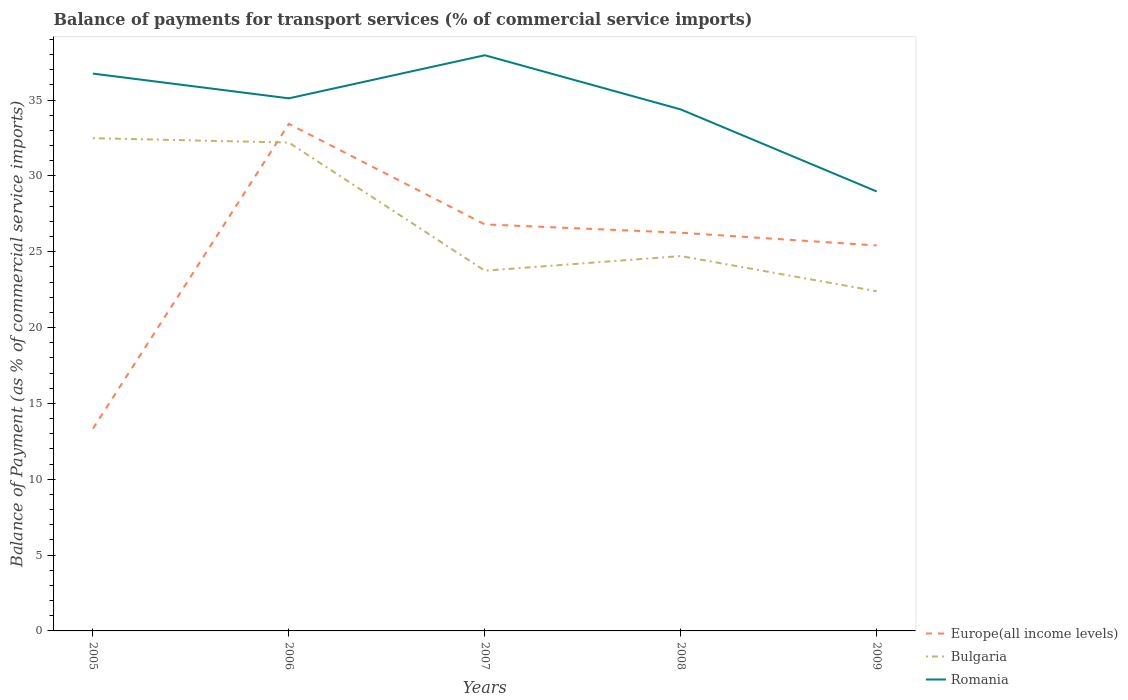How many different coloured lines are there?
Keep it short and to the point. 3. Does the line corresponding to Europe(all income levels) intersect with the line corresponding to Bulgaria?
Keep it short and to the point. Yes. Across all years, what is the maximum balance of payments for transport services in Bulgaria?
Give a very brief answer. 22.4. In which year was the balance of payments for transport services in Romania maximum?
Make the answer very short. 2009. What is the total balance of payments for transport services in Romania in the graph?
Make the answer very short. 5.41. What is the difference between the highest and the second highest balance of payments for transport services in Romania?
Your response must be concise. 8.98. What is the difference between the highest and the lowest balance of payments for transport services in Romania?
Ensure brevity in your answer.  3. Is the balance of payments for transport services in Bulgaria strictly greater than the balance of payments for transport services in Romania over the years?
Your response must be concise. Yes. How many lines are there?
Your response must be concise. 3. How many years are there in the graph?
Offer a terse response. 5. What is the difference between two consecutive major ticks on the Y-axis?
Provide a succinct answer. 5. Are the values on the major ticks of Y-axis written in scientific E-notation?
Give a very brief answer. No. Does the graph contain grids?
Provide a short and direct response. No. Where does the legend appear in the graph?
Provide a succinct answer. Bottom right. How are the legend labels stacked?
Make the answer very short. Vertical. What is the title of the graph?
Your answer should be compact. Balance of payments for transport services (% of commercial service imports). What is the label or title of the X-axis?
Keep it short and to the point. Years. What is the label or title of the Y-axis?
Offer a terse response. Balance of Payment (as % of commercial service imports). What is the Balance of Payment (as % of commercial service imports) of Europe(all income levels) in 2005?
Provide a short and direct response. 13.34. What is the Balance of Payment (as % of commercial service imports) of Bulgaria in 2005?
Offer a very short reply. 32.49. What is the Balance of Payment (as % of commercial service imports) of Romania in 2005?
Make the answer very short. 36.75. What is the Balance of Payment (as % of commercial service imports) of Europe(all income levels) in 2006?
Your answer should be very brief. 33.44. What is the Balance of Payment (as % of commercial service imports) of Bulgaria in 2006?
Your answer should be compact. 32.2. What is the Balance of Payment (as % of commercial service imports) of Romania in 2006?
Provide a succinct answer. 35.12. What is the Balance of Payment (as % of commercial service imports) in Europe(all income levels) in 2007?
Keep it short and to the point. 26.81. What is the Balance of Payment (as % of commercial service imports) of Bulgaria in 2007?
Offer a terse response. 23.75. What is the Balance of Payment (as % of commercial service imports) in Romania in 2007?
Make the answer very short. 37.96. What is the Balance of Payment (as % of commercial service imports) of Europe(all income levels) in 2008?
Ensure brevity in your answer.  26.26. What is the Balance of Payment (as % of commercial service imports) of Bulgaria in 2008?
Make the answer very short. 24.72. What is the Balance of Payment (as % of commercial service imports) of Romania in 2008?
Give a very brief answer. 34.39. What is the Balance of Payment (as % of commercial service imports) in Europe(all income levels) in 2009?
Provide a short and direct response. 25.42. What is the Balance of Payment (as % of commercial service imports) of Bulgaria in 2009?
Your answer should be very brief. 22.4. What is the Balance of Payment (as % of commercial service imports) in Romania in 2009?
Offer a very short reply. 28.98. Across all years, what is the maximum Balance of Payment (as % of commercial service imports) of Europe(all income levels)?
Keep it short and to the point. 33.44. Across all years, what is the maximum Balance of Payment (as % of commercial service imports) in Bulgaria?
Keep it short and to the point. 32.49. Across all years, what is the maximum Balance of Payment (as % of commercial service imports) in Romania?
Offer a very short reply. 37.96. Across all years, what is the minimum Balance of Payment (as % of commercial service imports) of Europe(all income levels)?
Provide a succinct answer. 13.34. Across all years, what is the minimum Balance of Payment (as % of commercial service imports) of Bulgaria?
Ensure brevity in your answer.  22.4. Across all years, what is the minimum Balance of Payment (as % of commercial service imports) in Romania?
Your answer should be compact. 28.98. What is the total Balance of Payment (as % of commercial service imports) of Europe(all income levels) in the graph?
Your answer should be very brief. 125.26. What is the total Balance of Payment (as % of commercial service imports) in Bulgaria in the graph?
Your answer should be compact. 135.57. What is the total Balance of Payment (as % of commercial service imports) of Romania in the graph?
Your answer should be very brief. 173.2. What is the difference between the Balance of Payment (as % of commercial service imports) in Europe(all income levels) in 2005 and that in 2006?
Your answer should be compact. -20.1. What is the difference between the Balance of Payment (as % of commercial service imports) of Bulgaria in 2005 and that in 2006?
Ensure brevity in your answer.  0.29. What is the difference between the Balance of Payment (as % of commercial service imports) of Romania in 2005 and that in 2006?
Your response must be concise. 1.63. What is the difference between the Balance of Payment (as % of commercial service imports) in Europe(all income levels) in 2005 and that in 2007?
Offer a terse response. -13.47. What is the difference between the Balance of Payment (as % of commercial service imports) in Bulgaria in 2005 and that in 2007?
Provide a succinct answer. 8.74. What is the difference between the Balance of Payment (as % of commercial service imports) in Romania in 2005 and that in 2007?
Keep it short and to the point. -1.21. What is the difference between the Balance of Payment (as % of commercial service imports) of Europe(all income levels) in 2005 and that in 2008?
Your answer should be compact. -12.92. What is the difference between the Balance of Payment (as % of commercial service imports) of Bulgaria in 2005 and that in 2008?
Offer a very short reply. 7.77. What is the difference between the Balance of Payment (as % of commercial service imports) of Romania in 2005 and that in 2008?
Your response must be concise. 2.36. What is the difference between the Balance of Payment (as % of commercial service imports) of Europe(all income levels) in 2005 and that in 2009?
Keep it short and to the point. -12.08. What is the difference between the Balance of Payment (as % of commercial service imports) in Bulgaria in 2005 and that in 2009?
Ensure brevity in your answer.  10.09. What is the difference between the Balance of Payment (as % of commercial service imports) of Romania in 2005 and that in 2009?
Make the answer very short. 7.77. What is the difference between the Balance of Payment (as % of commercial service imports) in Europe(all income levels) in 2006 and that in 2007?
Ensure brevity in your answer.  6.63. What is the difference between the Balance of Payment (as % of commercial service imports) of Bulgaria in 2006 and that in 2007?
Provide a short and direct response. 8.45. What is the difference between the Balance of Payment (as % of commercial service imports) in Romania in 2006 and that in 2007?
Offer a very short reply. -2.84. What is the difference between the Balance of Payment (as % of commercial service imports) of Europe(all income levels) in 2006 and that in 2008?
Provide a short and direct response. 7.18. What is the difference between the Balance of Payment (as % of commercial service imports) in Bulgaria in 2006 and that in 2008?
Provide a short and direct response. 7.48. What is the difference between the Balance of Payment (as % of commercial service imports) of Romania in 2006 and that in 2008?
Ensure brevity in your answer.  0.73. What is the difference between the Balance of Payment (as % of commercial service imports) of Europe(all income levels) in 2006 and that in 2009?
Provide a short and direct response. 8.02. What is the difference between the Balance of Payment (as % of commercial service imports) in Bulgaria in 2006 and that in 2009?
Ensure brevity in your answer.  9.8. What is the difference between the Balance of Payment (as % of commercial service imports) of Romania in 2006 and that in 2009?
Your response must be concise. 6.14. What is the difference between the Balance of Payment (as % of commercial service imports) of Europe(all income levels) in 2007 and that in 2008?
Keep it short and to the point. 0.55. What is the difference between the Balance of Payment (as % of commercial service imports) in Bulgaria in 2007 and that in 2008?
Offer a terse response. -0.96. What is the difference between the Balance of Payment (as % of commercial service imports) in Romania in 2007 and that in 2008?
Make the answer very short. 3.57. What is the difference between the Balance of Payment (as % of commercial service imports) of Europe(all income levels) in 2007 and that in 2009?
Ensure brevity in your answer.  1.39. What is the difference between the Balance of Payment (as % of commercial service imports) in Bulgaria in 2007 and that in 2009?
Provide a short and direct response. 1.35. What is the difference between the Balance of Payment (as % of commercial service imports) in Romania in 2007 and that in 2009?
Your answer should be very brief. 8.98. What is the difference between the Balance of Payment (as % of commercial service imports) in Europe(all income levels) in 2008 and that in 2009?
Offer a very short reply. 0.84. What is the difference between the Balance of Payment (as % of commercial service imports) of Bulgaria in 2008 and that in 2009?
Keep it short and to the point. 2.32. What is the difference between the Balance of Payment (as % of commercial service imports) of Romania in 2008 and that in 2009?
Keep it short and to the point. 5.41. What is the difference between the Balance of Payment (as % of commercial service imports) in Europe(all income levels) in 2005 and the Balance of Payment (as % of commercial service imports) in Bulgaria in 2006?
Make the answer very short. -18.87. What is the difference between the Balance of Payment (as % of commercial service imports) of Europe(all income levels) in 2005 and the Balance of Payment (as % of commercial service imports) of Romania in 2006?
Your answer should be very brief. -21.78. What is the difference between the Balance of Payment (as % of commercial service imports) of Bulgaria in 2005 and the Balance of Payment (as % of commercial service imports) of Romania in 2006?
Make the answer very short. -2.63. What is the difference between the Balance of Payment (as % of commercial service imports) of Europe(all income levels) in 2005 and the Balance of Payment (as % of commercial service imports) of Bulgaria in 2007?
Your answer should be very brief. -10.42. What is the difference between the Balance of Payment (as % of commercial service imports) in Europe(all income levels) in 2005 and the Balance of Payment (as % of commercial service imports) in Romania in 2007?
Give a very brief answer. -24.62. What is the difference between the Balance of Payment (as % of commercial service imports) of Bulgaria in 2005 and the Balance of Payment (as % of commercial service imports) of Romania in 2007?
Ensure brevity in your answer.  -5.47. What is the difference between the Balance of Payment (as % of commercial service imports) of Europe(all income levels) in 2005 and the Balance of Payment (as % of commercial service imports) of Bulgaria in 2008?
Make the answer very short. -11.38. What is the difference between the Balance of Payment (as % of commercial service imports) in Europe(all income levels) in 2005 and the Balance of Payment (as % of commercial service imports) in Romania in 2008?
Provide a short and direct response. -21.05. What is the difference between the Balance of Payment (as % of commercial service imports) of Bulgaria in 2005 and the Balance of Payment (as % of commercial service imports) of Romania in 2008?
Ensure brevity in your answer.  -1.89. What is the difference between the Balance of Payment (as % of commercial service imports) of Europe(all income levels) in 2005 and the Balance of Payment (as % of commercial service imports) of Bulgaria in 2009?
Provide a succinct answer. -9.06. What is the difference between the Balance of Payment (as % of commercial service imports) of Europe(all income levels) in 2005 and the Balance of Payment (as % of commercial service imports) of Romania in 2009?
Give a very brief answer. -15.64. What is the difference between the Balance of Payment (as % of commercial service imports) in Bulgaria in 2005 and the Balance of Payment (as % of commercial service imports) in Romania in 2009?
Your answer should be compact. 3.51. What is the difference between the Balance of Payment (as % of commercial service imports) in Europe(all income levels) in 2006 and the Balance of Payment (as % of commercial service imports) in Bulgaria in 2007?
Give a very brief answer. 9.68. What is the difference between the Balance of Payment (as % of commercial service imports) in Europe(all income levels) in 2006 and the Balance of Payment (as % of commercial service imports) in Romania in 2007?
Offer a very short reply. -4.53. What is the difference between the Balance of Payment (as % of commercial service imports) in Bulgaria in 2006 and the Balance of Payment (as % of commercial service imports) in Romania in 2007?
Keep it short and to the point. -5.76. What is the difference between the Balance of Payment (as % of commercial service imports) of Europe(all income levels) in 2006 and the Balance of Payment (as % of commercial service imports) of Bulgaria in 2008?
Offer a terse response. 8.72. What is the difference between the Balance of Payment (as % of commercial service imports) in Europe(all income levels) in 2006 and the Balance of Payment (as % of commercial service imports) in Romania in 2008?
Offer a terse response. -0.95. What is the difference between the Balance of Payment (as % of commercial service imports) in Bulgaria in 2006 and the Balance of Payment (as % of commercial service imports) in Romania in 2008?
Give a very brief answer. -2.19. What is the difference between the Balance of Payment (as % of commercial service imports) of Europe(all income levels) in 2006 and the Balance of Payment (as % of commercial service imports) of Bulgaria in 2009?
Give a very brief answer. 11.04. What is the difference between the Balance of Payment (as % of commercial service imports) of Europe(all income levels) in 2006 and the Balance of Payment (as % of commercial service imports) of Romania in 2009?
Keep it short and to the point. 4.46. What is the difference between the Balance of Payment (as % of commercial service imports) in Bulgaria in 2006 and the Balance of Payment (as % of commercial service imports) in Romania in 2009?
Keep it short and to the point. 3.22. What is the difference between the Balance of Payment (as % of commercial service imports) in Europe(all income levels) in 2007 and the Balance of Payment (as % of commercial service imports) in Bulgaria in 2008?
Provide a succinct answer. 2.09. What is the difference between the Balance of Payment (as % of commercial service imports) of Europe(all income levels) in 2007 and the Balance of Payment (as % of commercial service imports) of Romania in 2008?
Your answer should be very brief. -7.58. What is the difference between the Balance of Payment (as % of commercial service imports) in Bulgaria in 2007 and the Balance of Payment (as % of commercial service imports) in Romania in 2008?
Offer a terse response. -10.63. What is the difference between the Balance of Payment (as % of commercial service imports) of Europe(all income levels) in 2007 and the Balance of Payment (as % of commercial service imports) of Bulgaria in 2009?
Your response must be concise. 4.41. What is the difference between the Balance of Payment (as % of commercial service imports) in Europe(all income levels) in 2007 and the Balance of Payment (as % of commercial service imports) in Romania in 2009?
Your answer should be very brief. -2.17. What is the difference between the Balance of Payment (as % of commercial service imports) in Bulgaria in 2007 and the Balance of Payment (as % of commercial service imports) in Romania in 2009?
Offer a very short reply. -5.22. What is the difference between the Balance of Payment (as % of commercial service imports) of Europe(all income levels) in 2008 and the Balance of Payment (as % of commercial service imports) of Bulgaria in 2009?
Keep it short and to the point. 3.86. What is the difference between the Balance of Payment (as % of commercial service imports) in Europe(all income levels) in 2008 and the Balance of Payment (as % of commercial service imports) in Romania in 2009?
Give a very brief answer. -2.72. What is the difference between the Balance of Payment (as % of commercial service imports) of Bulgaria in 2008 and the Balance of Payment (as % of commercial service imports) of Romania in 2009?
Provide a short and direct response. -4.26. What is the average Balance of Payment (as % of commercial service imports) of Europe(all income levels) per year?
Give a very brief answer. 25.05. What is the average Balance of Payment (as % of commercial service imports) of Bulgaria per year?
Keep it short and to the point. 27.11. What is the average Balance of Payment (as % of commercial service imports) in Romania per year?
Offer a terse response. 34.64. In the year 2005, what is the difference between the Balance of Payment (as % of commercial service imports) in Europe(all income levels) and Balance of Payment (as % of commercial service imports) in Bulgaria?
Keep it short and to the point. -19.16. In the year 2005, what is the difference between the Balance of Payment (as % of commercial service imports) in Europe(all income levels) and Balance of Payment (as % of commercial service imports) in Romania?
Your response must be concise. -23.41. In the year 2005, what is the difference between the Balance of Payment (as % of commercial service imports) of Bulgaria and Balance of Payment (as % of commercial service imports) of Romania?
Your answer should be compact. -4.26. In the year 2006, what is the difference between the Balance of Payment (as % of commercial service imports) in Europe(all income levels) and Balance of Payment (as % of commercial service imports) in Bulgaria?
Give a very brief answer. 1.23. In the year 2006, what is the difference between the Balance of Payment (as % of commercial service imports) of Europe(all income levels) and Balance of Payment (as % of commercial service imports) of Romania?
Give a very brief answer. -1.68. In the year 2006, what is the difference between the Balance of Payment (as % of commercial service imports) of Bulgaria and Balance of Payment (as % of commercial service imports) of Romania?
Your answer should be compact. -2.92. In the year 2007, what is the difference between the Balance of Payment (as % of commercial service imports) of Europe(all income levels) and Balance of Payment (as % of commercial service imports) of Bulgaria?
Provide a succinct answer. 3.05. In the year 2007, what is the difference between the Balance of Payment (as % of commercial service imports) of Europe(all income levels) and Balance of Payment (as % of commercial service imports) of Romania?
Offer a very short reply. -11.15. In the year 2007, what is the difference between the Balance of Payment (as % of commercial service imports) in Bulgaria and Balance of Payment (as % of commercial service imports) in Romania?
Offer a very short reply. -14.21. In the year 2008, what is the difference between the Balance of Payment (as % of commercial service imports) in Europe(all income levels) and Balance of Payment (as % of commercial service imports) in Bulgaria?
Make the answer very short. 1.54. In the year 2008, what is the difference between the Balance of Payment (as % of commercial service imports) of Europe(all income levels) and Balance of Payment (as % of commercial service imports) of Romania?
Offer a terse response. -8.13. In the year 2008, what is the difference between the Balance of Payment (as % of commercial service imports) in Bulgaria and Balance of Payment (as % of commercial service imports) in Romania?
Provide a short and direct response. -9.67. In the year 2009, what is the difference between the Balance of Payment (as % of commercial service imports) of Europe(all income levels) and Balance of Payment (as % of commercial service imports) of Bulgaria?
Your answer should be very brief. 3.02. In the year 2009, what is the difference between the Balance of Payment (as % of commercial service imports) in Europe(all income levels) and Balance of Payment (as % of commercial service imports) in Romania?
Your answer should be very brief. -3.56. In the year 2009, what is the difference between the Balance of Payment (as % of commercial service imports) of Bulgaria and Balance of Payment (as % of commercial service imports) of Romania?
Your answer should be very brief. -6.58. What is the ratio of the Balance of Payment (as % of commercial service imports) in Europe(all income levels) in 2005 to that in 2006?
Provide a short and direct response. 0.4. What is the ratio of the Balance of Payment (as % of commercial service imports) in Bulgaria in 2005 to that in 2006?
Offer a very short reply. 1.01. What is the ratio of the Balance of Payment (as % of commercial service imports) of Romania in 2005 to that in 2006?
Provide a short and direct response. 1.05. What is the ratio of the Balance of Payment (as % of commercial service imports) in Europe(all income levels) in 2005 to that in 2007?
Your answer should be very brief. 0.5. What is the ratio of the Balance of Payment (as % of commercial service imports) in Bulgaria in 2005 to that in 2007?
Your response must be concise. 1.37. What is the ratio of the Balance of Payment (as % of commercial service imports) of Romania in 2005 to that in 2007?
Keep it short and to the point. 0.97. What is the ratio of the Balance of Payment (as % of commercial service imports) of Europe(all income levels) in 2005 to that in 2008?
Provide a short and direct response. 0.51. What is the ratio of the Balance of Payment (as % of commercial service imports) in Bulgaria in 2005 to that in 2008?
Your answer should be very brief. 1.31. What is the ratio of the Balance of Payment (as % of commercial service imports) of Romania in 2005 to that in 2008?
Offer a very short reply. 1.07. What is the ratio of the Balance of Payment (as % of commercial service imports) in Europe(all income levels) in 2005 to that in 2009?
Ensure brevity in your answer.  0.52. What is the ratio of the Balance of Payment (as % of commercial service imports) in Bulgaria in 2005 to that in 2009?
Ensure brevity in your answer.  1.45. What is the ratio of the Balance of Payment (as % of commercial service imports) in Romania in 2005 to that in 2009?
Offer a terse response. 1.27. What is the ratio of the Balance of Payment (as % of commercial service imports) in Europe(all income levels) in 2006 to that in 2007?
Your response must be concise. 1.25. What is the ratio of the Balance of Payment (as % of commercial service imports) of Bulgaria in 2006 to that in 2007?
Your response must be concise. 1.36. What is the ratio of the Balance of Payment (as % of commercial service imports) in Romania in 2006 to that in 2007?
Provide a succinct answer. 0.93. What is the ratio of the Balance of Payment (as % of commercial service imports) of Europe(all income levels) in 2006 to that in 2008?
Give a very brief answer. 1.27. What is the ratio of the Balance of Payment (as % of commercial service imports) of Bulgaria in 2006 to that in 2008?
Offer a very short reply. 1.3. What is the ratio of the Balance of Payment (as % of commercial service imports) in Romania in 2006 to that in 2008?
Provide a succinct answer. 1.02. What is the ratio of the Balance of Payment (as % of commercial service imports) of Europe(all income levels) in 2006 to that in 2009?
Make the answer very short. 1.32. What is the ratio of the Balance of Payment (as % of commercial service imports) of Bulgaria in 2006 to that in 2009?
Ensure brevity in your answer.  1.44. What is the ratio of the Balance of Payment (as % of commercial service imports) of Romania in 2006 to that in 2009?
Offer a terse response. 1.21. What is the ratio of the Balance of Payment (as % of commercial service imports) in Europe(all income levels) in 2007 to that in 2008?
Give a very brief answer. 1.02. What is the ratio of the Balance of Payment (as % of commercial service imports) in Bulgaria in 2007 to that in 2008?
Your answer should be compact. 0.96. What is the ratio of the Balance of Payment (as % of commercial service imports) in Romania in 2007 to that in 2008?
Offer a very short reply. 1.1. What is the ratio of the Balance of Payment (as % of commercial service imports) of Europe(all income levels) in 2007 to that in 2009?
Ensure brevity in your answer.  1.05. What is the ratio of the Balance of Payment (as % of commercial service imports) in Bulgaria in 2007 to that in 2009?
Offer a terse response. 1.06. What is the ratio of the Balance of Payment (as % of commercial service imports) of Romania in 2007 to that in 2009?
Offer a very short reply. 1.31. What is the ratio of the Balance of Payment (as % of commercial service imports) of Europe(all income levels) in 2008 to that in 2009?
Your response must be concise. 1.03. What is the ratio of the Balance of Payment (as % of commercial service imports) of Bulgaria in 2008 to that in 2009?
Your response must be concise. 1.1. What is the ratio of the Balance of Payment (as % of commercial service imports) of Romania in 2008 to that in 2009?
Ensure brevity in your answer.  1.19. What is the difference between the highest and the second highest Balance of Payment (as % of commercial service imports) in Europe(all income levels)?
Ensure brevity in your answer.  6.63. What is the difference between the highest and the second highest Balance of Payment (as % of commercial service imports) of Bulgaria?
Keep it short and to the point. 0.29. What is the difference between the highest and the second highest Balance of Payment (as % of commercial service imports) in Romania?
Make the answer very short. 1.21. What is the difference between the highest and the lowest Balance of Payment (as % of commercial service imports) in Europe(all income levels)?
Offer a very short reply. 20.1. What is the difference between the highest and the lowest Balance of Payment (as % of commercial service imports) in Bulgaria?
Your answer should be very brief. 10.09. What is the difference between the highest and the lowest Balance of Payment (as % of commercial service imports) in Romania?
Your answer should be very brief. 8.98. 